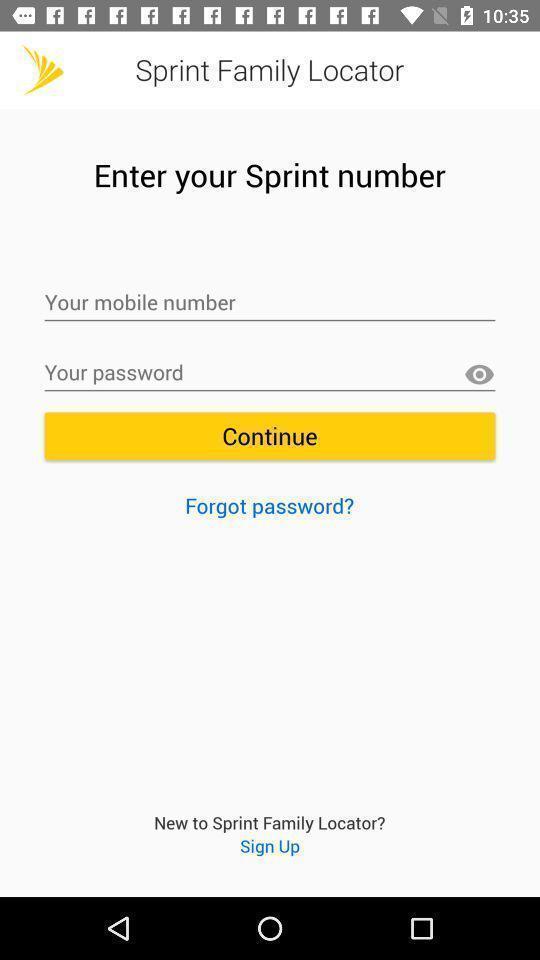What details can you identify in this image? Welcome page of a location application. 